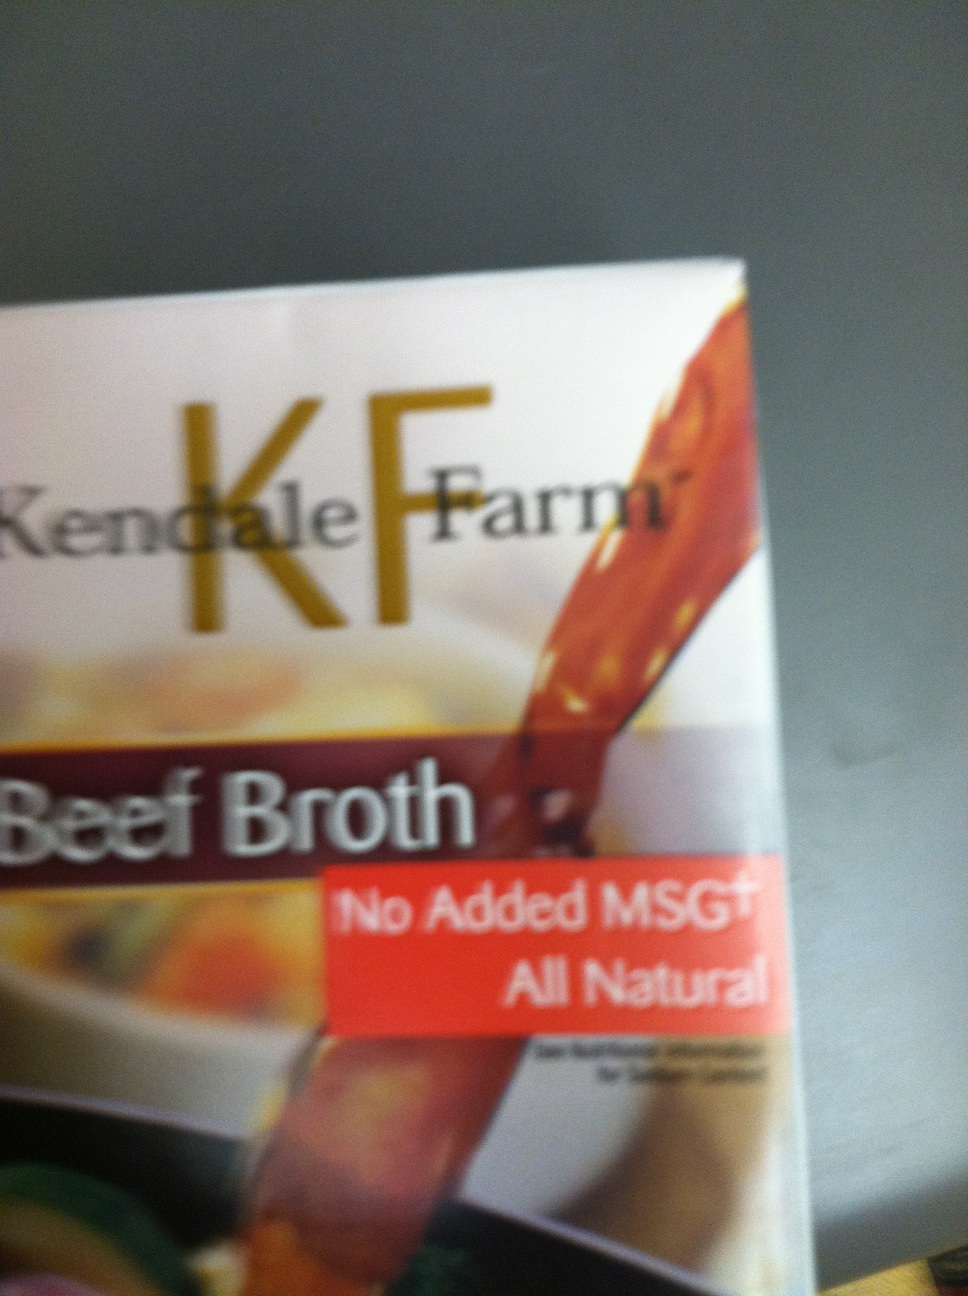What does 'All Natural' mean on this product? 'All Natural' on this beef broth product indicates that the ingredients used are free from synthetic additives, artificial colors, and preservatives. It suggests that the broth is made using natural ingredients, which may appeal to consumers looking for healthier and more wholesome food options. How does cooking with beef broth enhance the flavor of dishes? Cooking with beef broth enhances the flavor of dishes by adding a rich, savory depth that complements and elevates various ingredients. The natural beef flavor, combined with the umami notes, helps to round out the taste profile of soups, stews, risottos, and sauces. It can also be used to deglaze pans after browning meat, incorporating those flavorful browned bits into the sauce, further enriching the overall taste. In a realistic situation, how might a professional chef use this beef broth? In a professional kitchen, a chef might use this beef broth as a base for creating a French onion soup. They would caramelize onions slowly to develop a deep, sweet flavor, then deglaze the pan with a bit of white wine. After that, they would add the beef broth and let it simmer to allow the flavors to meld together. The soup would be ladled into bowls, topped with a slice of toasted baguette, and finished with melted Gruyère cheese under the broiler. The beef broth would provide a robust foundation, enhancing the soup's richness and depth. 